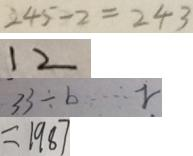<formula> <loc_0><loc_0><loc_500><loc_500>2 4 5 - 2 = 2 4 3 
 1 2 
 3 3 \div b \cdots r 
 = 1 9 8 7</formula> 